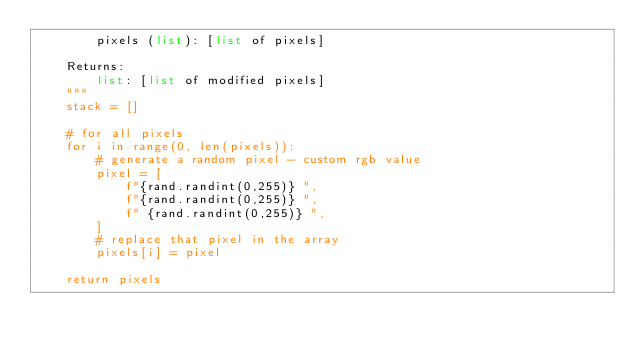Convert code to text. <code><loc_0><loc_0><loc_500><loc_500><_Python_>        pixels (list): [list of pixels]

    Returns:
        list: [list of modified pixels]
    """
    stack = []

    # for all pixels
    for i in range(0, len(pixels)):
        # generate a random pixel - custom rgb value
        pixel = [
            f"{rand.randint(0,255)} ",
            f"{rand.randint(0,255)} ",
            f" {rand.randint(0,255)} ",
        ]
        # replace that pixel in the array
        pixels[i] = pixel

    return pixels

</code> 